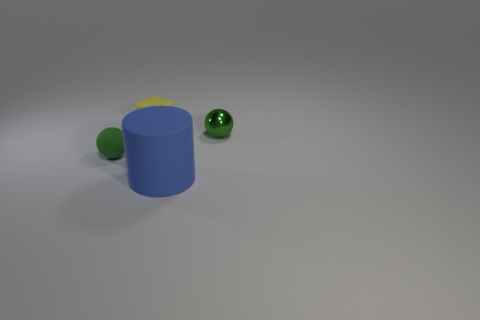Add 3 balls. How many objects exist? 7 Subtract all cylinders. How many objects are left? 3 Add 4 tiny balls. How many tiny balls are left? 6 Add 1 yellow matte cubes. How many yellow matte cubes exist? 2 Subtract 1 blue cylinders. How many objects are left? 3 Subtract all small objects. Subtract all tiny yellow matte blocks. How many objects are left? 0 